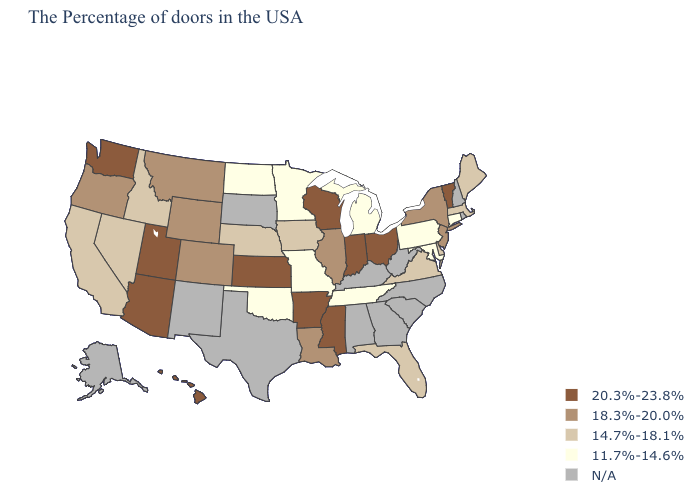Does Arkansas have the highest value in the USA?
Be succinct. Yes. Name the states that have a value in the range 14.7%-18.1%?
Keep it brief. Maine, Massachusetts, Delaware, Virginia, Florida, Iowa, Nebraska, Idaho, Nevada, California. Name the states that have a value in the range 18.3%-20.0%?
Short answer required. New York, New Jersey, Illinois, Louisiana, Wyoming, Colorado, Montana, Oregon. Which states have the highest value in the USA?
Quick response, please. Vermont, Ohio, Indiana, Wisconsin, Mississippi, Arkansas, Kansas, Utah, Arizona, Washington, Hawaii. How many symbols are there in the legend?
Quick response, please. 5. Is the legend a continuous bar?
Concise answer only. No. Does the first symbol in the legend represent the smallest category?
Write a very short answer. No. What is the lowest value in the USA?
Keep it brief. 11.7%-14.6%. What is the highest value in the USA?
Concise answer only. 20.3%-23.8%. What is the highest value in the USA?
Write a very short answer. 20.3%-23.8%. Does Maryland have the lowest value in the South?
Write a very short answer. Yes. What is the value of Wisconsin?
Short answer required. 20.3%-23.8%. Among the states that border North Dakota , does Minnesota have the lowest value?
Be succinct. Yes. Does Indiana have the highest value in the USA?
Concise answer only. Yes. 